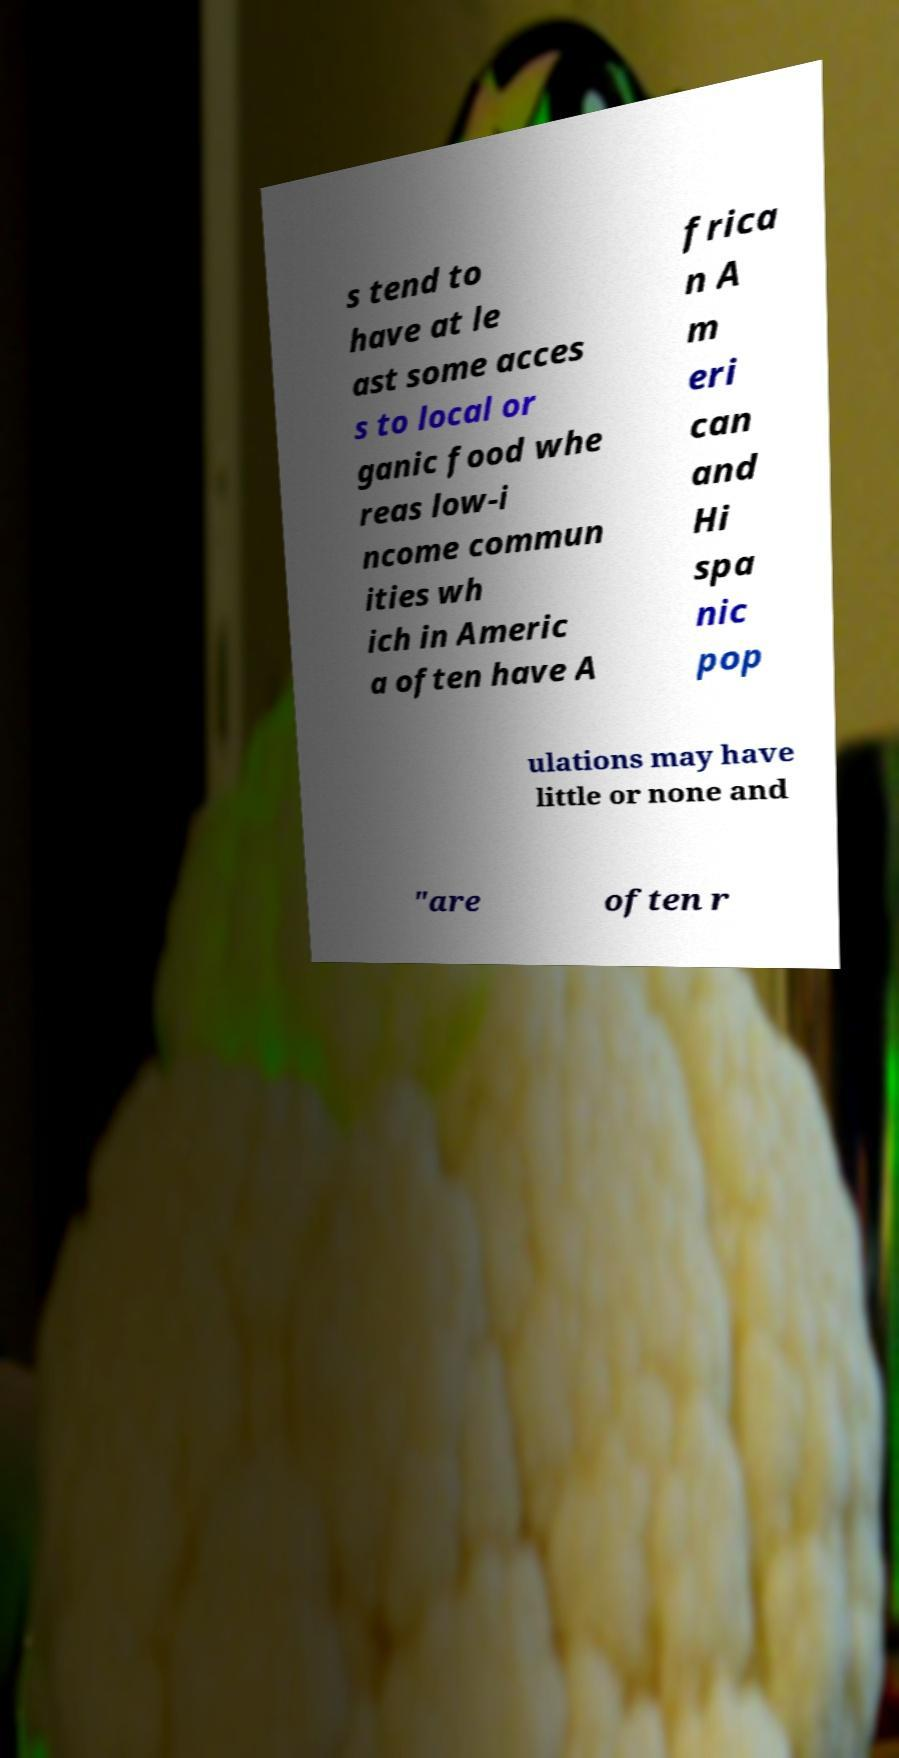Could you assist in decoding the text presented in this image and type it out clearly? s tend to have at le ast some acces s to local or ganic food whe reas low-i ncome commun ities wh ich in Americ a often have A frica n A m eri can and Hi spa nic pop ulations may have little or none and "are often r 